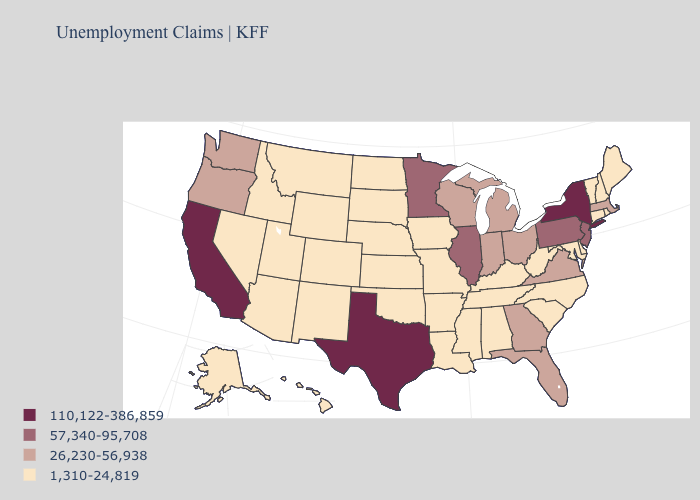Does the first symbol in the legend represent the smallest category?
Concise answer only. No. Name the states that have a value in the range 26,230-56,938?
Quick response, please. Florida, Georgia, Indiana, Massachusetts, Michigan, Ohio, Oregon, Virginia, Washington, Wisconsin. Name the states that have a value in the range 57,340-95,708?
Write a very short answer. Illinois, Minnesota, New Jersey, Pennsylvania. Does the first symbol in the legend represent the smallest category?
Be succinct. No. Does the first symbol in the legend represent the smallest category?
Write a very short answer. No. Does Wisconsin have a higher value than Florida?
Quick response, please. No. Does Michigan have the highest value in the MidWest?
Concise answer only. No. Among the states that border Pennsylvania , which have the lowest value?
Answer briefly. Delaware, Maryland, West Virginia. Name the states that have a value in the range 1,310-24,819?
Write a very short answer. Alabama, Alaska, Arizona, Arkansas, Colorado, Connecticut, Delaware, Hawaii, Idaho, Iowa, Kansas, Kentucky, Louisiana, Maine, Maryland, Mississippi, Missouri, Montana, Nebraska, Nevada, New Hampshire, New Mexico, North Carolina, North Dakota, Oklahoma, Rhode Island, South Carolina, South Dakota, Tennessee, Utah, Vermont, West Virginia, Wyoming. Among the states that border Delaware , does Pennsylvania have the lowest value?
Give a very brief answer. No. What is the value of New Hampshire?
Keep it brief. 1,310-24,819. Does Delaware have the same value as West Virginia?
Quick response, please. Yes. Does South Carolina have the highest value in the USA?
Answer briefly. No. What is the highest value in states that border Vermont?
Be succinct. 110,122-386,859. Does South Dakota have the same value as California?
Quick response, please. No. 